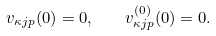<formula> <loc_0><loc_0><loc_500><loc_500>v _ { \kappa j p } ( 0 ) = 0 , \quad v _ { \kappa j p } ^ { ( 0 ) } ( 0 ) = 0 .</formula> 